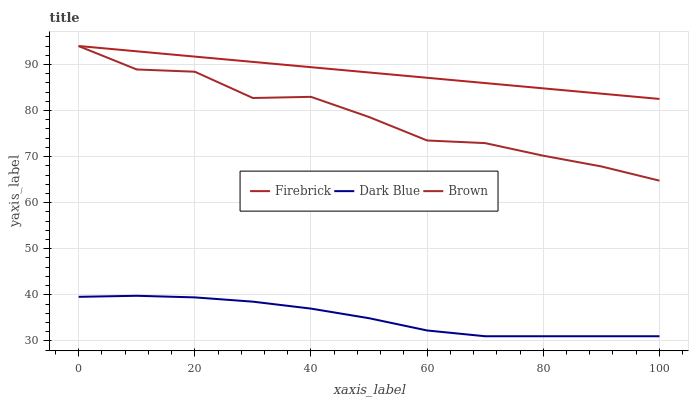Does Dark Blue have the minimum area under the curve?
Answer yes or no. Yes. Does Firebrick have the maximum area under the curve?
Answer yes or no. Yes. Does Brown have the minimum area under the curve?
Answer yes or no. No. Does Brown have the maximum area under the curve?
Answer yes or no. No. Is Firebrick the smoothest?
Answer yes or no. Yes. Is Brown the roughest?
Answer yes or no. Yes. Is Brown the smoothest?
Answer yes or no. No. Is Firebrick the roughest?
Answer yes or no. No. Does Dark Blue have the lowest value?
Answer yes or no. Yes. Does Brown have the lowest value?
Answer yes or no. No. Does Firebrick have the highest value?
Answer yes or no. Yes. Does Brown have the highest value?
Answer yes or no. No. Is Dark Blue less than Brown?
Answer yes or no. Yes. Is Firebrick greater than Dark Blue?
Answer yes or no. Yes. Does Dark Blue intersect Brown?
Answer yes or no. No. 